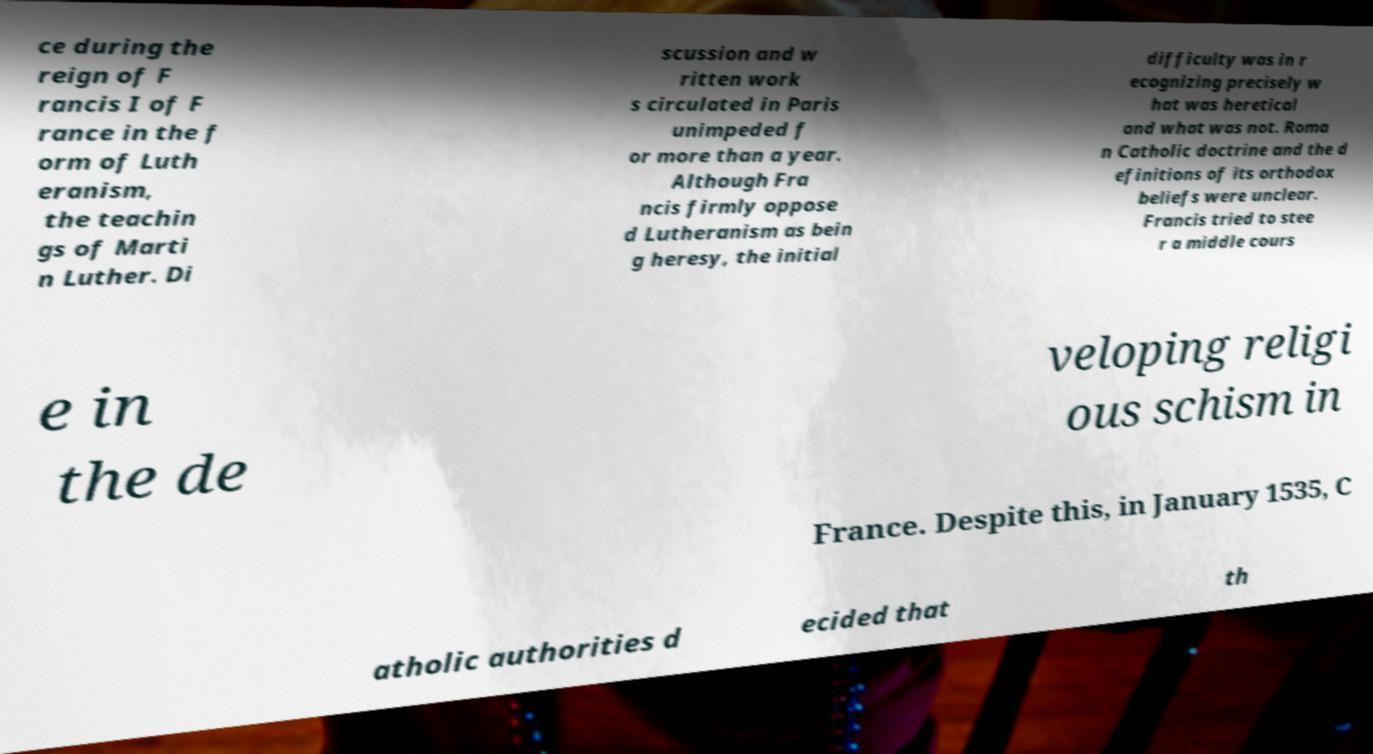Could you extract and type out the text from this image? ce during the reign of F rancis I of F rance in the f orm of Luth eranism, the teachin gs of Marti n Luther. Di scussion and w ritten work s circulated in Paris unimpeded f or more than a year. Although Fra ncis firmly oppose d Lutheranism as bein g heresy, the initial difficulty was in r ecognizing precisely w hat was heretical and what was not. Roma n Catholic doctrine and the d efinitions of its orthodox beliefs were unclear. Francis tried to stee r a middle cours e in the de veloping religi ous schism in France. Despite this, in January 1535, C atholic authorities d ecided that th 